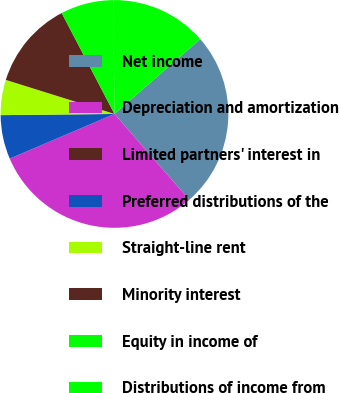<chart> <loc_0><loc_0><loc_500><loc_500><pie_chart><fcel>Net income<fcel>Depreciation and amortization<fcel>Limited partners' interest in<fcel>Preferred distributions of the<fcel>Straight-line rent<fcel>Minority interest<fcel>Equity in income of<fcel>Distributions of income from<nl><fcel>25.0%<fcel>30.0%<fcel>0.0%<fcel>6.25%<fcel>5.0%<fcel>12.5%<fcel>7.5%<fcel>13.75%<nl></chart> 